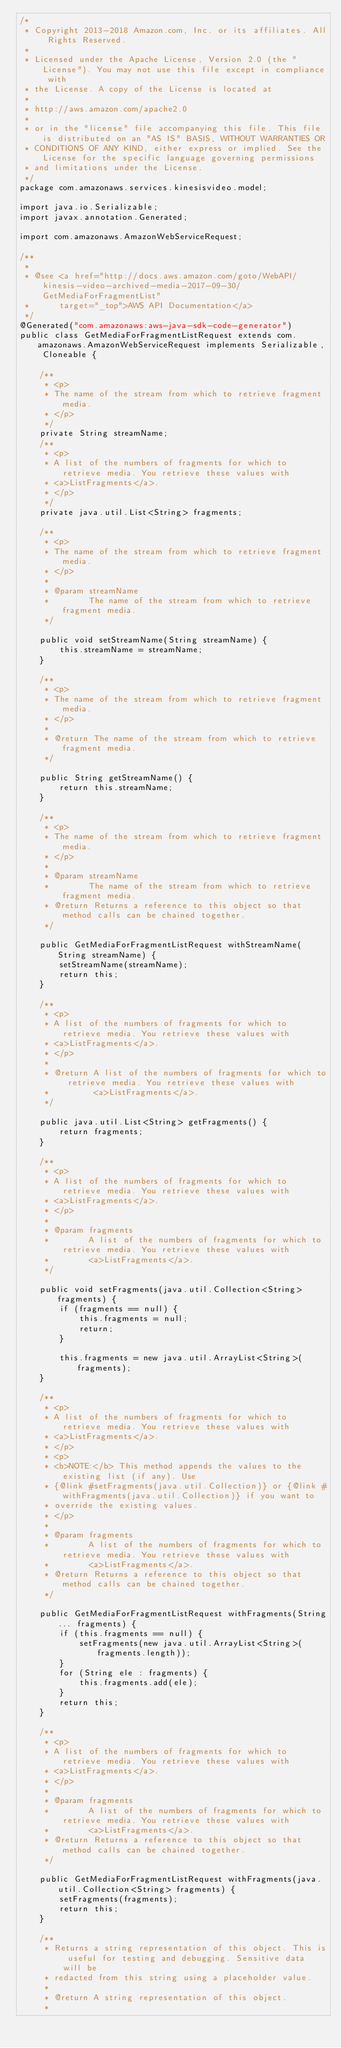Convert code to text. <code><loc_0><loc_0><loc_500><loc_500><_Java_>/*
 * Copyright 2013-2018 Amazon.com, Inc. or its affiliates. All Rights Reserved.
 * 
 * Licensed under the Apache License, Version 2.0 (the "License"). You may not use this file except in compliance with
 * the License. A copy of the License is located at
 * 
 * http://aws.amazon.com/apache2.0
 * 
 * or in the "license" file accompanying this file. This file is distributed on an "AS IS" BASIS, WITHOUT WARRANTIES OR
 * CONDITIONS OF ANY KIND, either express or implied. See the License for the specific language governing permissions
 * and limitations under the License.
 */
package com.amazonaws.services.kinesisvideo.model;

import java.io.Serializable;
import javax.annotation.Generated;

import com.amazonaws.AmazonWebServiceRequest;

/**
 * 
 * @see <a href="http://docs.aws.amazon.com/goto/WebAPI/kinesis-video-archived-media-2017-09-30/GetMediaForFragmentList"
 *      target="_top">AWS API Documentation</a>
 */
@Generated("com.amazonaws:aws-java-sdk-code-generator")
public class GetMediaForFragmentListRequest extends com.amazonaws.AmazonWebServiceRequest implements Serializable, Cloneable {

    /**
     * <p>
     * The name of the stream from which to retrieve fragment media.
     * </p>
     */
    private String streamName;
    /**
     * <p>
     * A list of the numbers of fragments for which to retrieve media. You retrieve these values with
     * <a>ListFragments</a>.
     * </p>
     */
    private java.util.List<String> fragments;

    /**
     * <p>
     * The name of the stream from which to retrieve fragment media.
     * </p>
     * 
     * @param streamName
     *        The name of the stream from which to retrieve fragment media.
     */

    public void setStreamName(String streamName) {
        this.streamName = streamName;
    }

    /**
     * <p>
     * The name of the stream from which to retrieve fragment media.
     * </p>
     * 
     * @return The name of the stream from which to retrieve fragment media.
     */

    public String getStreamName() {
        return this.streamName;
    }

    /**
     * <p>
     * The name of the stream from which to retrieve fragment media.
     * </p>
     * 
     * @param streamName
     *        The name of the stream from which to retrieve fragment media.
     * @return Returns a reference to this object so that method calls can be chained together.
     */

    public GetMediaForFragmentListRequest withStreamName(String streamName) {
        setStreamName(streamName);
        return this;
    }

    /**
     * <p>
     * A list of the numbers of fragments for which to retrieve media. You retrieve these values with
     * <a>ListFragments</a>.
     * </p>
     * 
     * @return A list of the numbers of fragments for which to retrieve media. You retrieve these values with
     *         <a>ListFragments</a>.
     */

    public java.util.List<String> getFragments() {
        return fragments;
    }

    /**
     * <p>
     * A list of the numbers of fragments for which to retrieve media. You retrieve these values with
     * <a>ListFragments</a>.
     * </p>
     * 
     * @param fragments
     *        A list of the numbers of fragments for which to retrieve media. You retrieve these values with
     *        <a>ListFragments</a>.
     */

    public void setFragments(java.util.Collection<String> fragments) {
        if (fragments == null) {
            this.fragments = null;
            return;
        }

        this.fragments = new java.util.ArrayList<String>(fragments);
    }

    /**
     * <p>
     * A list of the numbers of fragments for which to retrieve media. You retrieve these values with
     * <a>ListFragments</a>.
     * </p>
     * <p>
     * <b>NOTE:</b> This method appends the values to the existing list (if any). Use
     * {@link #setFragments(java.util.Collection)} or {@link #withFragments(java.util.Collection)} if you want to
     * override the existing values.
     * </p>
     * 
     * @param fragments
     *        A list of the numbers of fragments for which to retrieve media. You retrieve these values with
     *        <a>ListFragments</a>.
     * @return Returns a reference to this object so that method calls can be chained together.
     */

    public GetMediaForFragmentListRequest withFragments(String... fragments) {
        if (this.fragments == null) {
            setFragments(new java.util.ArrayList<String>(fragments.length));
        }
        for (String ele : fragments) {
            this.fragments.add(ele);
        }
        return this;
    }

    /**
     * <p>
     * A list of the numbers of fragments for which to retrieve media. You retrieve these values with
     * <a>ListFragments</a>.
     * </p>
     * 
     * @param fragments
     *        A list of the numbers of fragments for which to retrieve media. You retrieve these values with
     *        <a>ListFragments</a>.
     * @return Returns a reference to this object so that method calls can be chained together.
     */

    public GetMediaForFragmentListRequest withFragments(java.util.Collection<String> fragments) {
        setFragments(fragments);
        return this;
    }

    /**
     * Returns a string representation of this object. This is useful for testing and debugging. Sensitive data will be
     * redacted from this string using a placeholder value.
     *
     * @return A string representation of this object.
     *</code> 